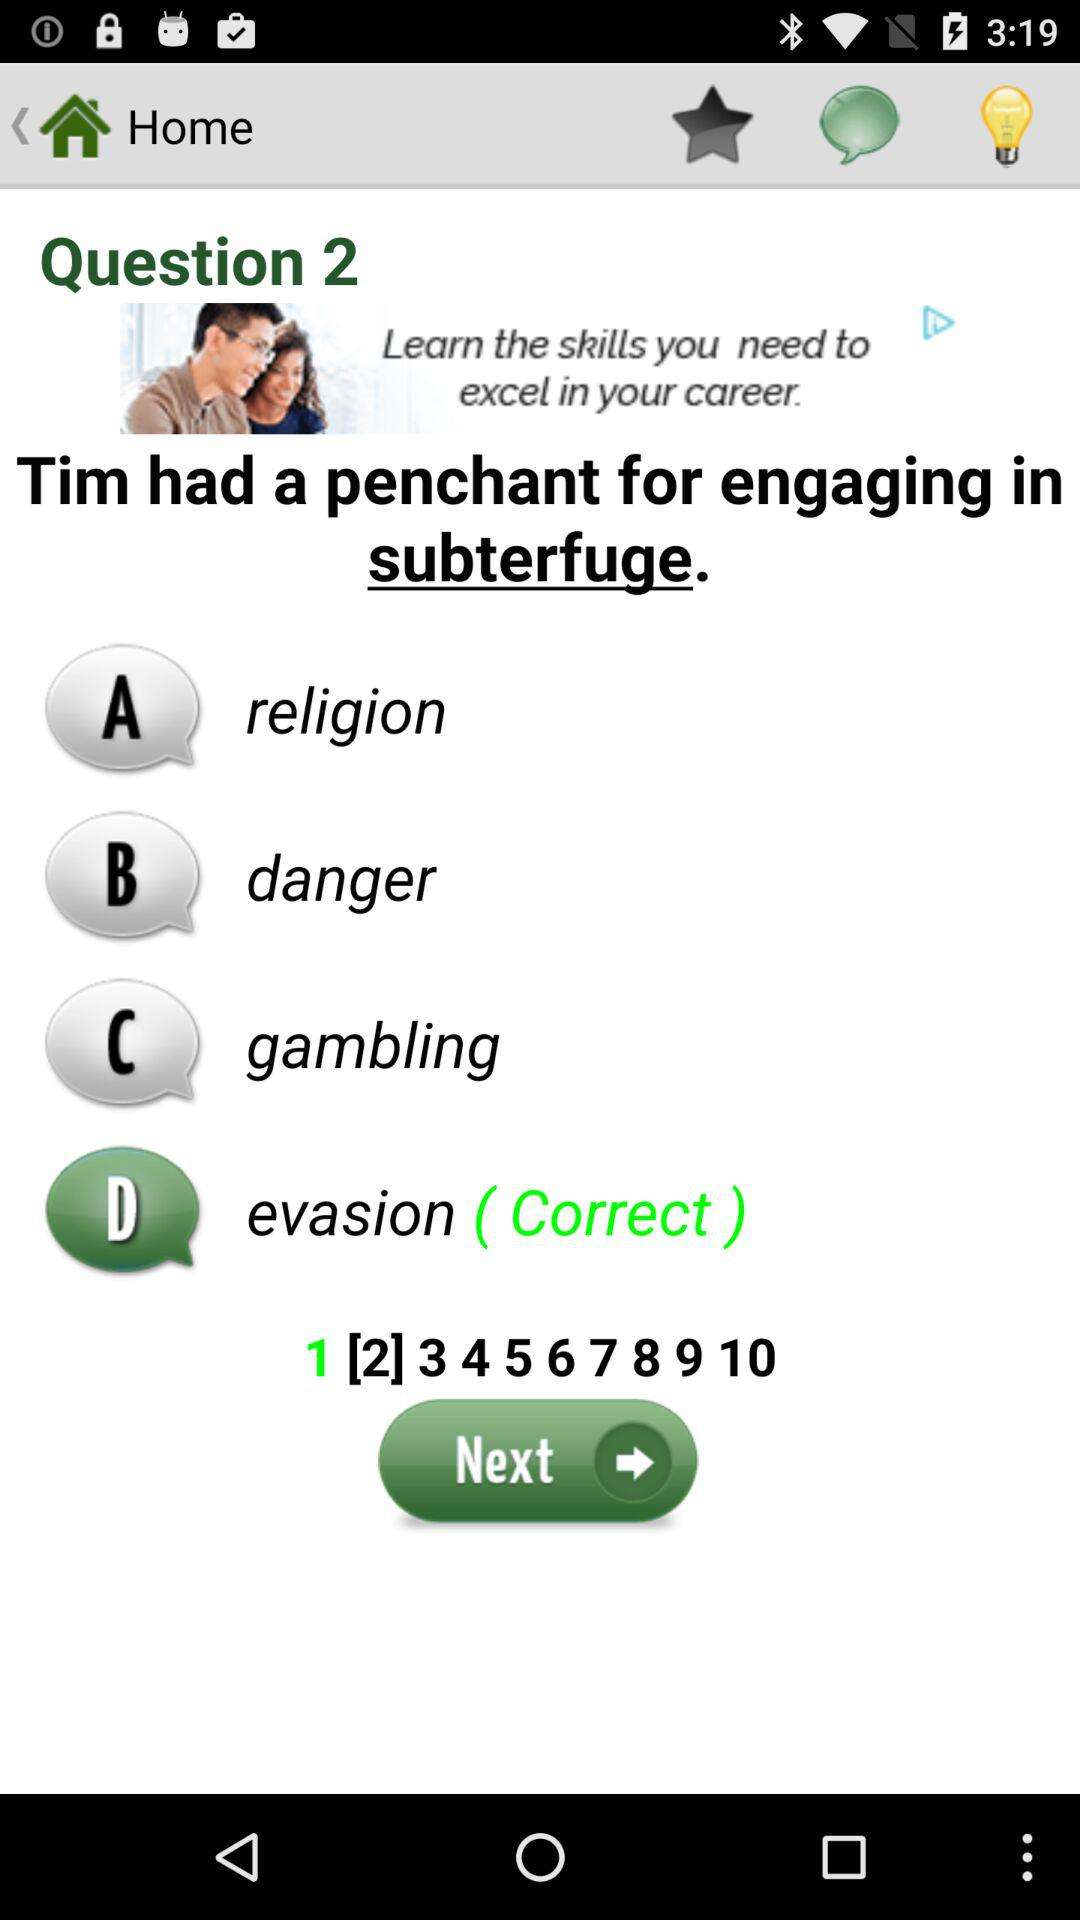At which question am I? You are at the second question. 